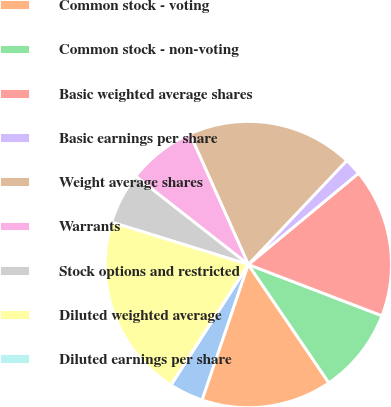Convert chart to OTSL. <chart><loc_0><loc_0><loc_500><loc_500><pie_chart><fcel>Net income<fcel>Common stock - voting<fcel>Common stock - non-voting<fcel>Basic weighted average shares<fcel>Basic earnings per share<fcel>Weight average shares<fcel>Warrants<fcel>Stock options and restricted<fcel>Diluted weighted average<fcel>Diluted earnings per share<nl><fcel>3.86%<fcel>14.74%<fcel>9.66%<fcel>16.83%<fcel>1.93%<fcel>18.76%<fcel>7.73%<fcel>5.79%<fcel>20.69%<fcel>0.0%<nl></chart> 